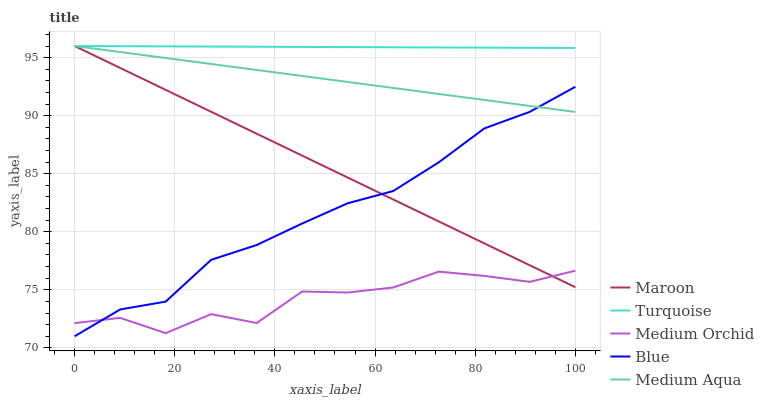Does Medium Orchid have the minimum area under the curve?
Answer yes or no. Yes. Does Turquoise have the maximum area under the curve?
Answer yes or no. Yes. Does Turquoise have the minimum area under the curve?
Answer yes or no. No. Does Medium Orchid have the maximum area under the curve?
Answer yes or no. No. Is Medium Aqua the smoothest?
Answer yes or no. Yes. Is Medium Orchid the roughest?
Answer yes or no. Yes. Is Turquoise the smoothest?
Answer yes or no. No. Is Turquoise the roughest?
Answer yes or no. No. Does Blue have the lowest value?
Answer yes or no. Yes. Does Medium Orchid have the lowest value?
Answer yes or no. No. Does Maroon have the highest value?
Answer yes or no. Yes. Does Medium Orchid have the highest value?
Answer yes or no. No. Is Blue less than Turquoise?
Answer yes or no. Yes. Is Medium Aqua greater than Medium Orchid?
Answer yes or no. Yes. Does Blue intersect Medium Aqua?
Answer yes or no. Yes. Is Blue less than Medium Aqua?
Answer yes or no. No. Is Blue greater than Medium Aqua?
Answer yes or no. No. Does Blue intersect Turquoise?
Answer yes or no. No. 